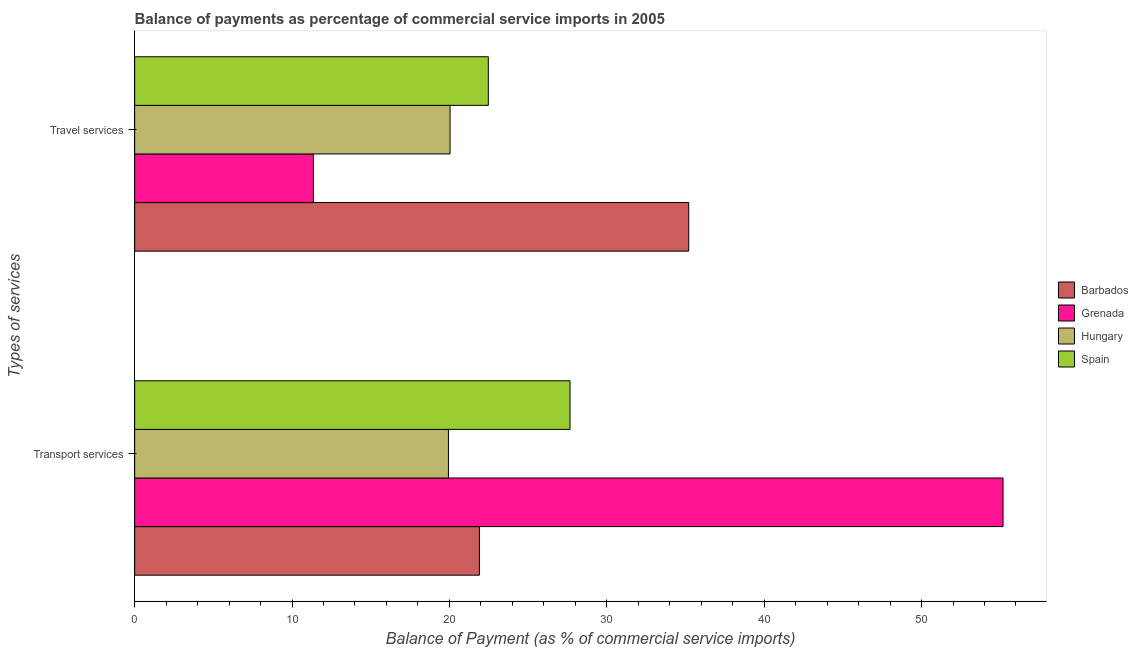Are the number of bars per tick equal to the number of legend labels?
Give a very brief answer. Yes. What is the label of the 2nd group of bars from the top?
Provide a short and direct response. Transport services. What is the balance of payments of transport services in Hungary?
Your answer should be very brief. 19.94. Across all countries, what is the maximum balance of payments of transport services?
Give a very brief answer. 55.18. Across all countries, what is the minimum balance of payments of transport services?
Your response must be concise. 19.94. In which country was the balance of payments of travel services maximum?
Your answer should be compact. Barbados. In which country was the balance of payments of travel services minimum?
Keep it short and to the point. Grenada. What is the total balance of payments of travel services in the graph?
Your answer should be very brief. 89.08. What is the difference between the balance of payments of transport services in Hungary and that in Barbados?
Ensure brevity in your answer.  -1.97. What is the difference between the balance of payments of transport services in Hungary and the balance of payments of travel services in Barbados?
Provide a succinct answer. -15.27. What is the average balance of payments of travel services per country?
Your answer should be compact. 22.27. What is the difference between the balance of payments of transport services and balance of payments of travel services in Hungary?
Your response must be concise. -0.1. In how many countries, is the balance of payments of transport services greater than 36 %?
Keep it short and to the point. 1. What is the ratio of the balance of payments of transport services in Hungary to that in Spain?
Give a very brief answer. 0.72. Is the balance of payments of travel services in Hungary less than that in Barbados?
Ensure brevity in your answer.  Yes. In how many countries, is the balance of payments of transport services greater than the average balance of payments of transport services taken over all countries?
Offer a very short reply. 1. What does the 3rd bar from the top in Travel services represents?
Offer a very short reply. Grenada. What does the 2nd bar from the bottom in Transport services represents?
Give a very brief answer. Grenada. Are all the bars in the graph horizontal?
Keep it short and to the point. Yes. Does the graph contain any zero values?
Ensure brevity in your answer.  No. Does the graph contain grids?
Provide a short and direct response. No. How many legend labels are there?
Give a very brief answer. 4. What is the title of the graph?
Your answer should be very brief. Balance of payments as percentage of commercial service imports in 2005. What is the label or title of the X-axis?
Ensure brevity in your answer.  Balance of Payment (as % of commercial service imports). What is the label or title of the Y-axis?
Your response must be concise. Types of services. What is the Balance of Payment (as % of commercial service imports) of Barbados in Transport services?
Your answer should be compact. 21.91. What is the Balance of Payment (as % of commercial service imports) of Grenada in Transport services?
Offer a terse response. 55.18. What is the Balance of Payment (as % of commercial service imports) in Hungary in Transport services?
Offer a very short reply. 19.94. What is the Balance of Payment (as % of commercial service imports) in Spain in Transport services?
Offer a very short reply. 27.66. What is the Balance of Payment (as % of commercial service imports) of Barbados in Travel services?
Offer a very short reply. 35.21. What is the Balance of Payment (as % of commercial service imports) of Grenada in Travel services?
Provide a short and direct response. 11.36. What is the Balance of Payment (as % of commercial service imports) of Hungary in Travel services?
Offer a terse response. 20.04. What is the Balance of Payment (as % of commercial service imports) in Spain in Travel services?
Your response must be concise. 22.47. Across all Types of services, what is the maximum Balance of Payment (as % of commercial service imports) in Barbados?
Offer a very short reply. 35.21. Across all Types of services, what is the maximum Balance of Payment (as % of commercial service imports) in Grenada?
Keep it short and to the point. 55.18. Across all Types of services, what is the maximum Balance of Payment (as % of commercial service imports) in Hungary?
Make the answer very short. 20.04. Across all Types of services, what is the maximum Balance of Payment (as % of commercial service imports) in Spain?
Offer a terse response. 27.66. Across all Types of services, what is the minimum Balance of Payment (as % of commercial service imports) in Barbados?
Give a very brief answer. 21.91. Across all Types of services, what is the minimum Balance of Payment (as % of commercial service imports) in Grenada?
Your answer should be compact. 11.36. Across all Types of services, what is the minimum Balance of Payment (as % of commercial service imports) in Hungary?
Make the answer very short. 19.94. Across all Types of services, what is the minimum Balance of Payment (as % of commercial service imports) of Spain?
Make the answer very short. 22.47. What is the total Balance of Payment (as % of commercial service imports) of Barbados in the graph?
Make the answer very short. 57.11. What is the total Balance of Payment (as % of commercial service imports) in Grenada in the graph?
Your answer should be very brief. 66.54. What is the total Balance of Payment (as % of commercial service imports) in Hungary in the graph?
Offer a terse response. 39.98. What is the total Balance of Payment (as % of commercial service imports) of Spain in the graph?
Offer a terse response. 50.14. What is the difference between the Balance of Payment (as % of commercial service imports) in Barbados in Transport services and that in Travel services?
Your answer should be compact. -13.3. What is the difference between the Balance of Payment (as % of commercial service imports) in Grenada in Transport services and that in Travel services?
Ensure brevity in your answer.  43.82. What is the difference between the Balance of Payment (as % of commercial service imports) of Hungary in Transport services and that in Travel services?
Give a very brief answer. -0.1. What is the difference between the Balance of Payment (as % of commercial service imports) in Spain in Transport services and that in Travel services?
Give a very brief answer. 5.19. What is the difference between the Balance of Payment (as % of commercial service imports) of Barbados in Transport services and the Balance of Payment (as % of commercial service imports) of Grenada in Travel services?
Provide a succinct answer. 10.55. What is the difference between the Balance of Payment (as % of commercial service imports) in Barbados in Transport services and the Balance of Payment (as % of commercial service imports) in Hungary in Travel services?
Your response must be concise. 1.86. What is the difference between the Balance of Payment (as % of commercial service imports) of Barbados in Transport services and the Balance of Payment (as % of commercial service imports) of Spain in Travel services?
Your response must be concise. -0.57. What is the difference between the Balance of Payment (as % of commercial service imports) in Grenada in Transport services and the Balance of Payment (as % of commercial service imports) in Hungary in Travel services?
Your answer should be compact. 35.14. What is the difference between the Balance of Payment (as % of commercial service imports) of Grenada in Transport services and the Balance of Payment (as % of commercial service imports) of Spain in Travel services?
Provide a short and direct response. 32.71. What is the difference between the Balance of Payment (as % of commercial service imports) of Hungary in Transport services and the Balance of Payment (as % of commercial service imports) of Spain in Travel services?
Your response must be concise. -2.53. What is the average Balance of Payment (as % of commercial service imports) of Barbados per Types of services?
Offer a terse response. 28.56. What is the average Balance of Payment (as % of commercial service imports) of Grenada per Types of services?
Your answer should be very brief. 33.27. What is the average Balance of Payment (as % of commercial service imports) in Hungary per Types of services?
Keep it short and to the point. 19.99. What is the average Balance of Payment (as % of commercial service imports) of Spain per Types of services?
Offer a very short reply. 25.07. What is the difference between the Balance of Payment (as % of commercial service imports) of Barbados and Balance of Payment (as % of commercial service imports) of Grenada in Transport services?
Your answer should be very brief. -33.27. What is the difference between the Balance of Payment (as % of commercial service imports) in Barbados and Balance of Payment (as % of commercial service imports) in Hungary in Transport services?
Offer a very short reply. 1.97. What is the difference between the Balance of Payment (as % of commercial service imports) of Barbados and Balance of Payment (as % of commercial service imports) of Spain in Transport services?
Provide a short and direct response. -5.76. What is the difference between the Balance of Payment (as % of commercial service imports) in Grenada and Balance of Payment (as % of commercial service imports) in Hungary in Transport services?
Provide a short and direct response. 35.24. What is the difference between the Balance of Payment (as % of commercial service imports) in Grenada and Balance of Payment (as % of commercial service imports) in Spain in Transport services?
Keep it short and to the point. 27.52. What is the difference between the Balance of Payment (as % of commercial service imports) in Hungary and Balance of Payment (as % of commercial service imports) in Spain in Transport services?
Your answer should be compact. -7.73. What is the difference between the Balance of Payment (as % of commercial service imports) of Barbados and Balance of Payment (as % of commercial service imports) of Grenada in Travel services?
Give a very brief answer. 23.85. What is the difference between the Balance of Payment (as % of commercial service imports) in Barbados and Balance of Payment (as % of commercial service imports) in Hungary in Travel services?
Make the answer very short. 15.16. What is the difference between the Balance of Payment (as % of commercial service imports) in Barbados and Balance of Payment (as % of commercial service imports) in Spain in Travel services?
Your answer should be compact. 12.73. What is the difference between the Balance of Payment (as % of commercial service imports) of Grenada and Balance of Payment (as % of commercial service imports) of Hungary in Travel services?
Your response must be concise. -8.68. What is the difference between the Balance of Payment (as % of commercial service imports) in Grenada and Balance of Payment (as % of commercial service imports) in Spain in Travel services?
Give a very brief answer. -11.11. What is the difference between the Balance of Payment (as % of commercial service imports) of Hungary and Balance of Payment (as % of commercial service imports) of Spain in Travel services?
Offer a terse response. -2.43. What is the ratio of the Balance of Payment (as % of commercial service imports) in Barbados in Transport services to that in Travel services?
Ensure brevity in your answer.  0.62. What is the ratio of the Balance of Payment (as % of commercial service imports) in Grenada in Transport services to that in Travel services?
Offer a terse response. 4.86. What is the ratio of the Balance of Payment (as % of commercial service imports) of Hungary in Transport services to that in Travel services?
Give a very brief answer. 0.99. What is the ratio of the Balance of Payment (as % of commercial service imports) of Spain in Transport services to that in Travel services?
Provide a succinct answer. 1.23. What is the difference between the highest and the second highest Balance of Payment (as % of commercial service imports) in Barbados?
Ensure brevity in your answer.  13.3. What is the difference between the highest and the second highest Balance of Payment (as % of commercial service imports) in Grenada?
Offer a very short reply. 43.82. What is the difference between the highest and the second highest Balance of Payment (as % of commercial service imports) of Hungary?
Your response must be concise. 0.1. What is the difference between the highest and the second highest Balance of Payment (as % of commercial service imports) in Spain?
Ensure brevity in your answer.  5.19. What is the difference between the highest and the lowest Balance of Payment (as % of commercial service imports) in Barbados?
Your response must be concise. 13.3. What is the difference between the highest and the lowest Balance of Payment (as % of commercial service imports) of Grenada?
Offer a terse response. 43.82. What is the difference between the highest and the lowest Balance of Payment (as % of commercial service imports) in Hungary?
Make the answer very short. 0.1. What is the difference between the highest and the lowest Balance of Payment (as % of commercial service imports) of Spain?
Offer a very short reply. 5.19. 